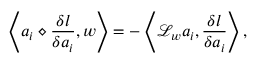<formula> <loc_0><loc_0><loc_500><loc_500>\left \langle a _ { i } \diamond \frac { \delta l } { \delta a _ { i } } , w \right \rangle = - \left \langle \mathcal { L } _ { w } a _ { i } , \frac { \delta l } { \delta a _ { i } } \right \rangle ,</formula> 